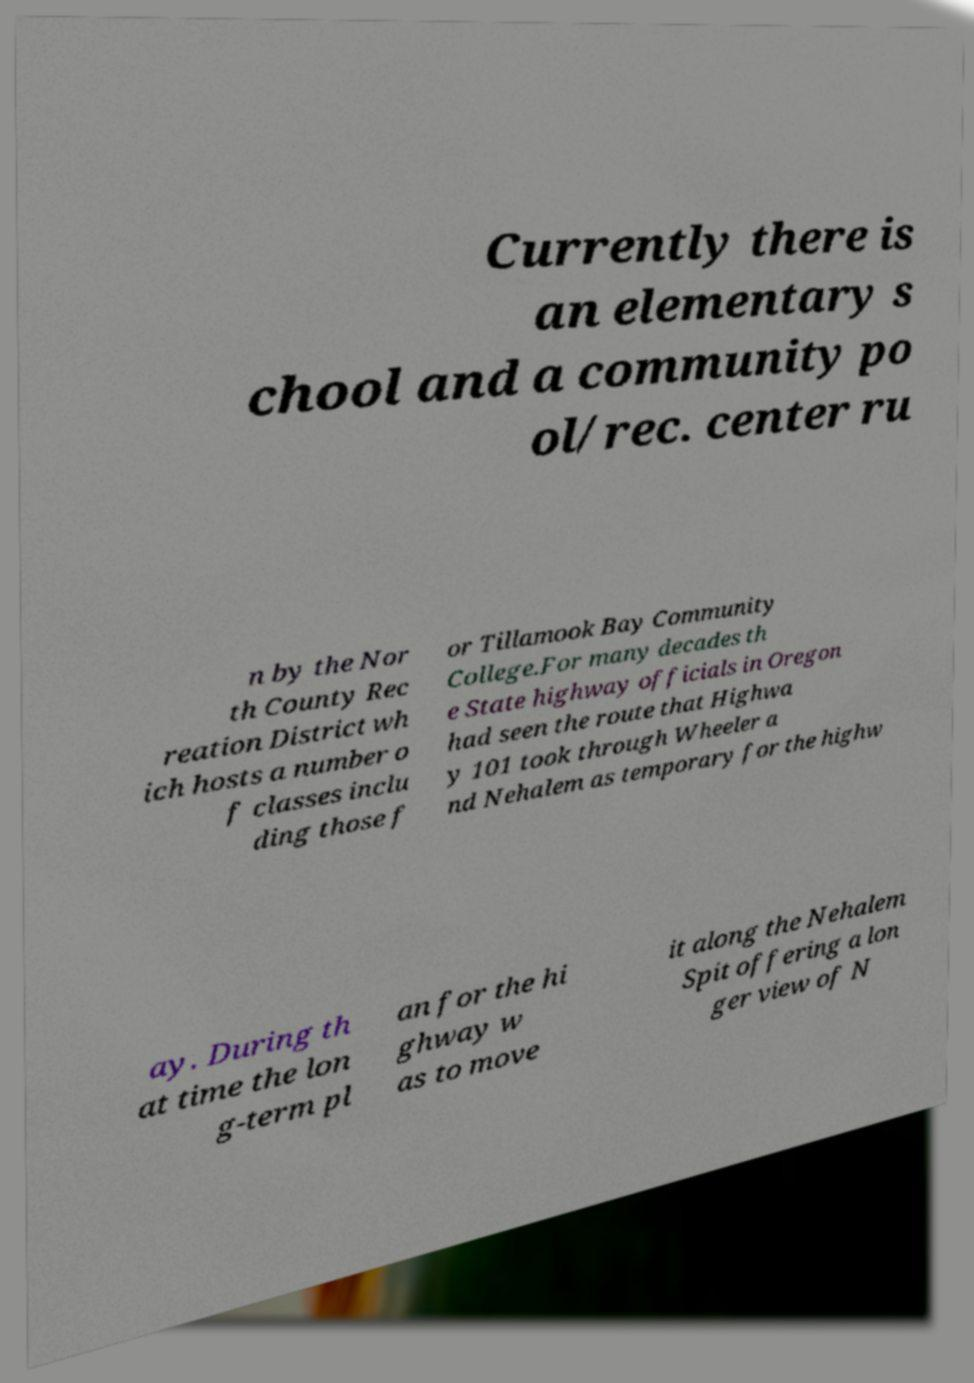Can you accurately transcribe the text from the provided image for me? Currently there is an elementary s chool and a community po ol/rec. center ru n by the Nor th County Rec reation District wh ich hosts a number o f classes inclu ding those f or Tillamook Bay Community College.For many decades th e State highway officials in Oregon had seen the route that Highwa y 101 took through Wheeler a nd Nehalem as temporary for the highw ay. During th at time the lon g-term pl an for the hi ghway w as to move it along the Nehalem Spit offering a lon ger view of N 